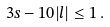Convert formula to latex. <formula><loc_0><loc_0><loc_500><loc_500>3 s - 1 0 | l | \leq 1 \, .</formula> 